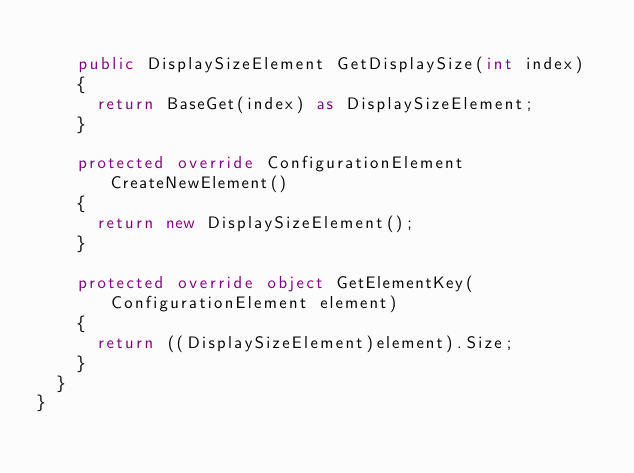<code> <loc_0><loc_0><loc_500><loc_500><_C#_>
		public DisplaySizeElement GetDisplaySize(int index)
		{
			return BaseGet(index) as DisplaySizeElement;
		}

		protected override ConfigurationElement CreateNewElement()
		{
			return new DisplaySizeElement();
		}

		protected override object GetElementKey(ConfigurationElement element)
		{
			return ((DisplaySizeElement)element).Size;
		}
	}
}
</code> 